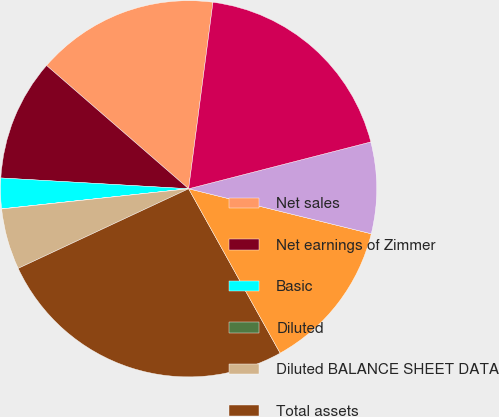Convert chart. <chart><loc_0><loc_0><loc_500><loc_500><pie_chart><fcel>Net sales<fcel>Net earnings of Zimmer<fcel>Basic<fcel>Diluted<fcel>Diluted BALANCE SHEET DATA<fcel>Total assets<fcel>Long-term debt<fcel>Other long-term obligations<fcel>Stockholders' equity<nl><fcel>15.69%<fcel>10.46%<fcel>2.62%<fcel>0.01%<fcel>5.24%<fcel>26.13%<fcel>13.07%<fcel>7.85%<fcel>18.93%<nl></chart> 